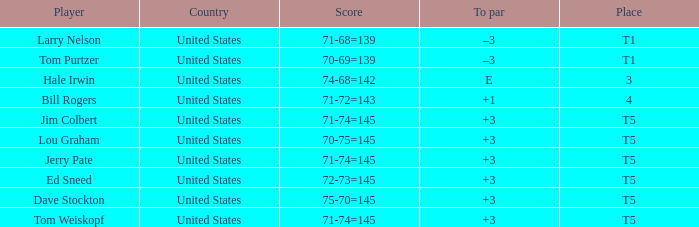Who is the player with a t5 place and a 75-70=145 score? Dave Stockton. 